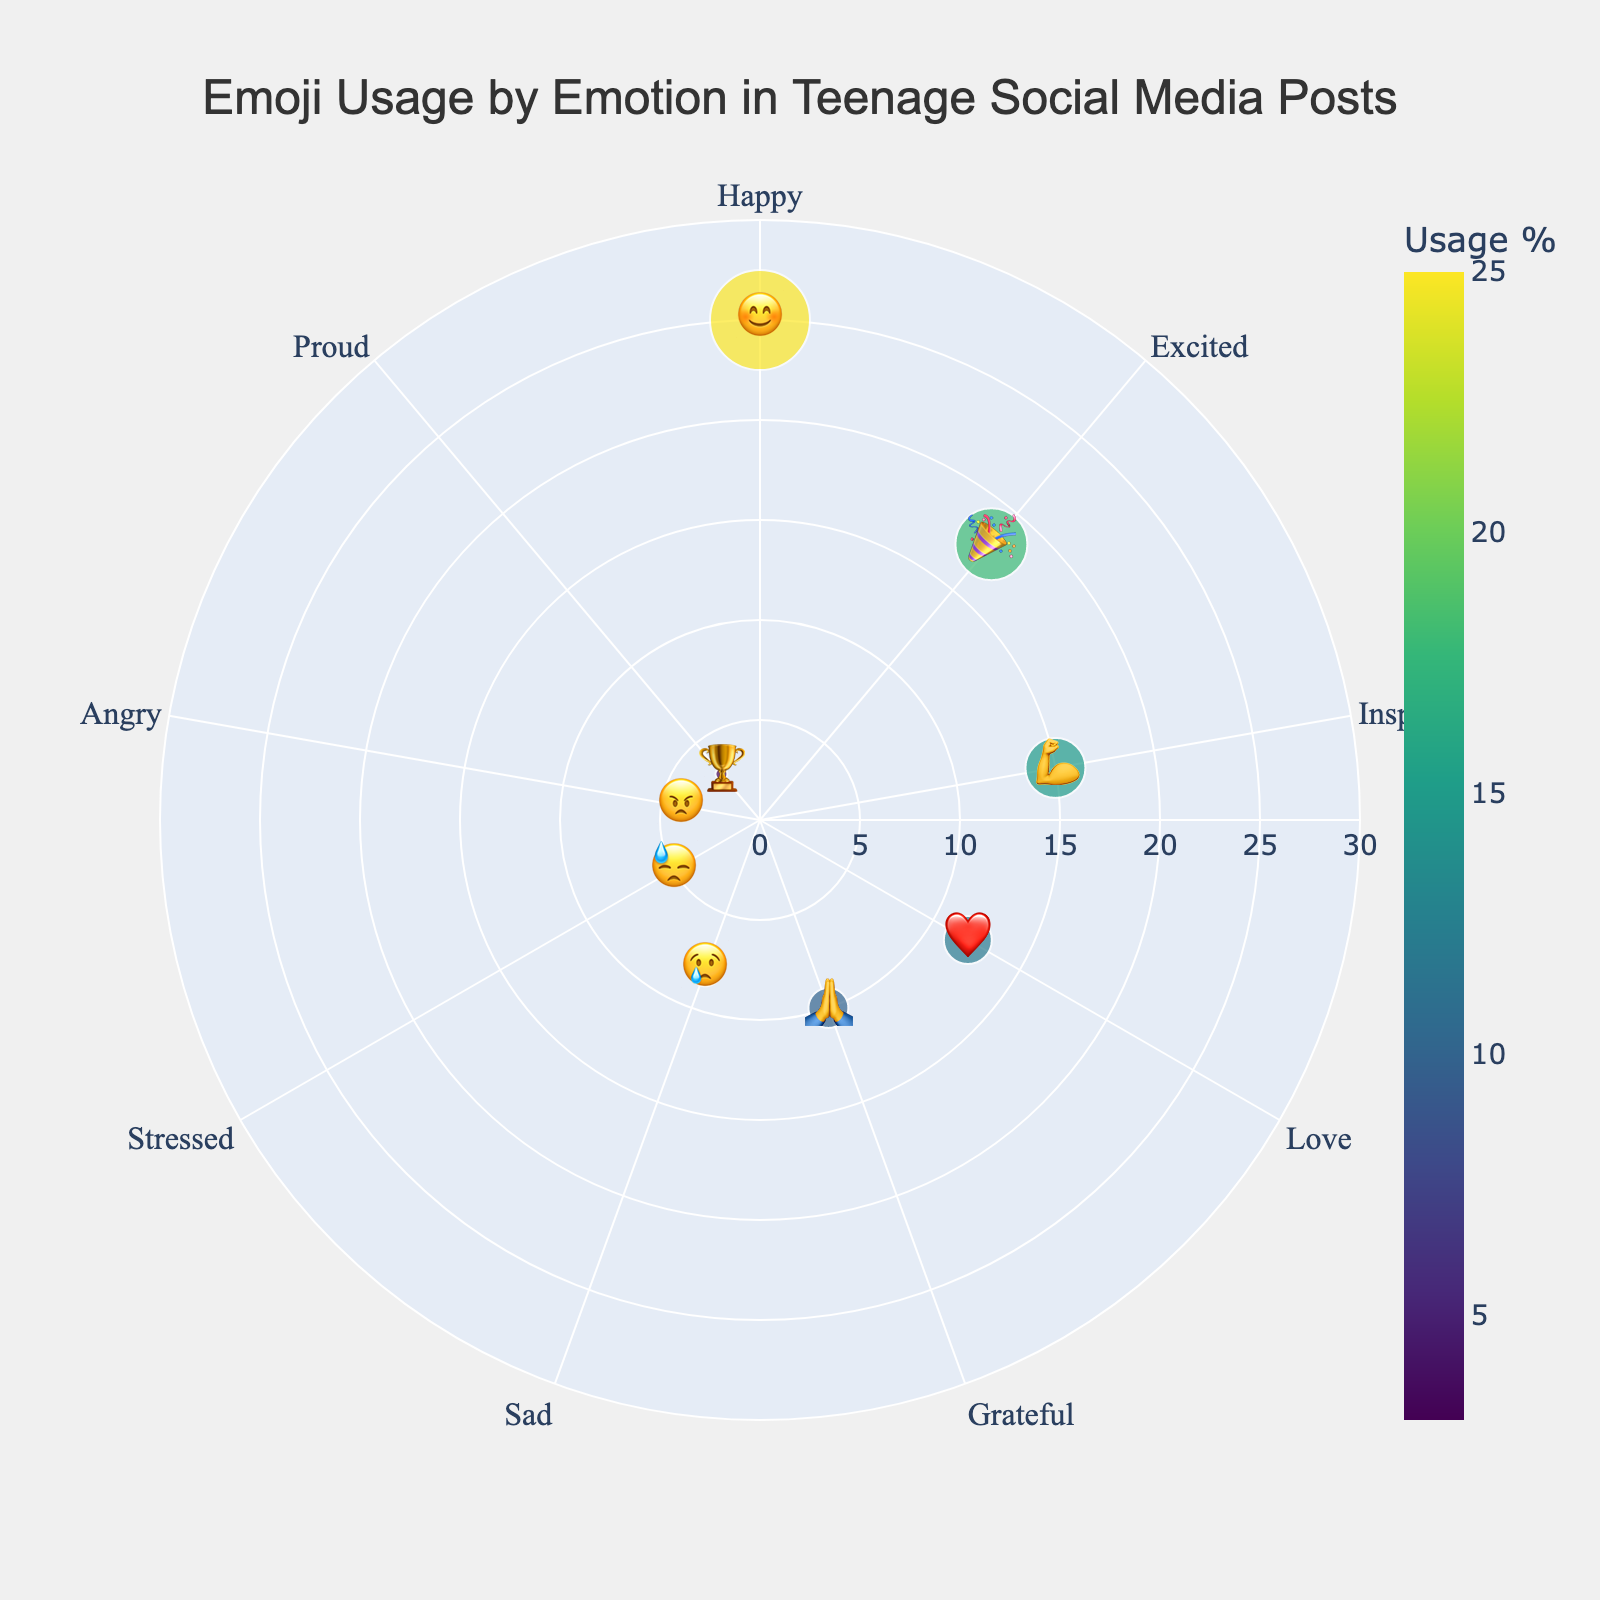What's the title of the chart? The title is located at the top center of the chart. It is clearly indicated in large font.
Answer: Emoji Usage by Emotion in Teenage Social Media Posts Which emoji corresponds to the highest usage percentage? By locating the emojis and their corresponding usage percentages, the largest value indicates the highest usage. The "😊" emoji has the highest usage percentage at 25%.
Answer: 😊 What is the combined usage percentage of the "Excited" and "Happy" emojis? Add the usage percentages of "Excited" (18%) and "Happy" (25%) emojis: 18 + 25 = 43%.
Answer: 43% Which two emotions have the smallest usage percentages, and what are they? Identify the two smallest values in the dataset, which are "Proud" (3%) and "Angry" (4%).
Answer: Proud (🏆) and Angry (😠) How much higher is the usage of "Grateful" (🙏) compared to "Sad" (😢)? Subtract the usage percentage of "Sad" (8%) from "Grateful" (10%): 10 - 8 = 2%.
Answer: 2% Rank the emojis by usage percentage from highest to lowest. Organize the emojis based on their usage percentage in descending order: 😊 (25%), 🎉 (18%), 💪 (15%), ❤️ (12%), 🙏 (10%), 😢 (8%), 😓 (5%), 😠 (4%), 🏆 (3%).
Answer: 😊, 🎉, 💪, ❤️, 🙏, 😢, 😓, 😠, 🏆 Which emoji is situated at the center of the polar chart with the highest radius value? The emoji with the highest radius value on the polar chart is located at the center with the highest numerical value on the radius axis: "😊" with 25%.
Answer: 😊 What percentage of usage is attributed to emotions categorized as negative (Sad, Stressed, and Angry)? Sum the usage percentages of the negative emotions: Sad (8%), Stressed (5%), and Angry (4%): 8 + 5 + 4 = 17%.
Answer: 17% Is the usage percentage of "Love" (❤️) greater than or less than "Inspired" (💪)? Compare the usage percentages: "Love" (12%) is less than "Inspired" (15%).
Answer: Less than Which emotions are more frequently expressed using emojis: positive or negative? Positive emotions (Happy, Excited, Inspired, Love, Grateful, Proud) total: 25 + 18 + 15 + 12 + 10 + 3 = 83%. Negative emotions (Sad, Stressed, Angry) total: 8 + 5 + 4 = 17%. Positive emotions are more frequent.
Answer: Positive 